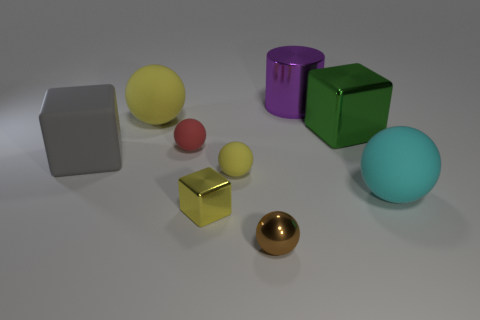What number of objects are cyan matte balls that are right of the brown metallic object or small metal things?
Offer a terse response. 3. Is the number of green blocks that are to the right of the small red ball the same as the number of large metallic cubes?
Offer a very short reply. Yes. Is the yellow shiny thing the same size as the metal sphere?
Offer a very short reply. Yes. What is the color of the shiny ball that is the same size as the yellow metal thing?
Provide a succinct answer. Brown. Do the red matte ball and the shiny thing that is to the left of the tiny yellow rubber sphere have the same size?
Offer a terse response. Yes. How many big matte things have the same color as the shiny sphere?
Provide a succinct answer. 0. What number of objects are small things or shiny things on the right side of the big purple thing?
Ensure brevity in your answer.  5. There is a metallic object left of the brown shiny ball; does it have the same size as the cube that is on the left side of the big yellow rubber thing?
Give a very brief answer. No. Are there any large green objects made of the same material as the brown ball?
Keep it short and to the point. Yes. The red matte thing has what shape?
Offer a terse response. Sphere. 